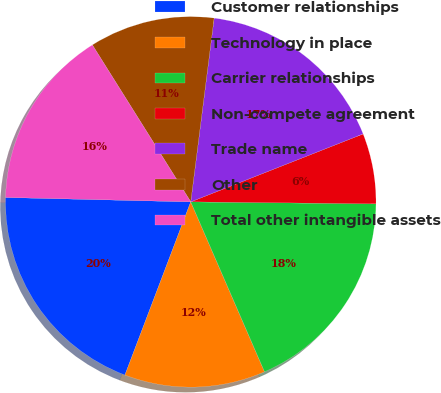Convert chart. <chart><loc_0><loc_0><loc_500><loc_500><pie_chart><fcel>Customer relationships<fcel>Technology in place<fcel>Carrier relationships<fcel>Non-compete agreement<fcel>Trade name<fcel>Other<fcel>Total other intangible assets<nl><fcel>19.6%<fcel>12.3%<fcel>18.31%<fcel>6.15%<fcel>17.01%<fcel>10.93%<fcel>15.71%<nl></chart> 